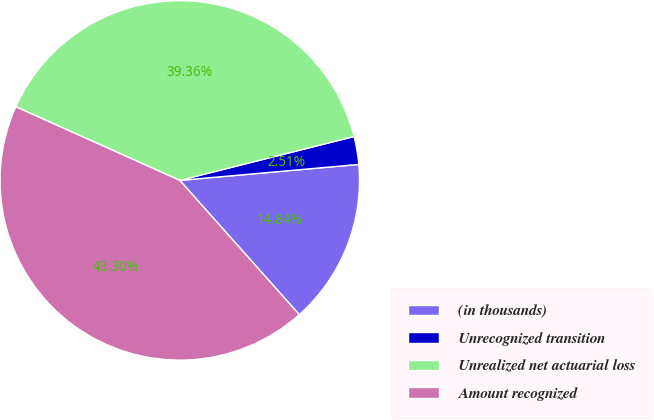Convert chart. <chart><loc_0><loc_0><loc_500><loc_500><pie_chart><fcel>(in thousands)<fcel>Unrecognized transition<fcel>Unrealized net actuarial loss<fcel>Amount recognized<nl><fcel>14.84%<fcel>2.51%<fcel>39.36%<fcel>43.3%<nl></chart> 